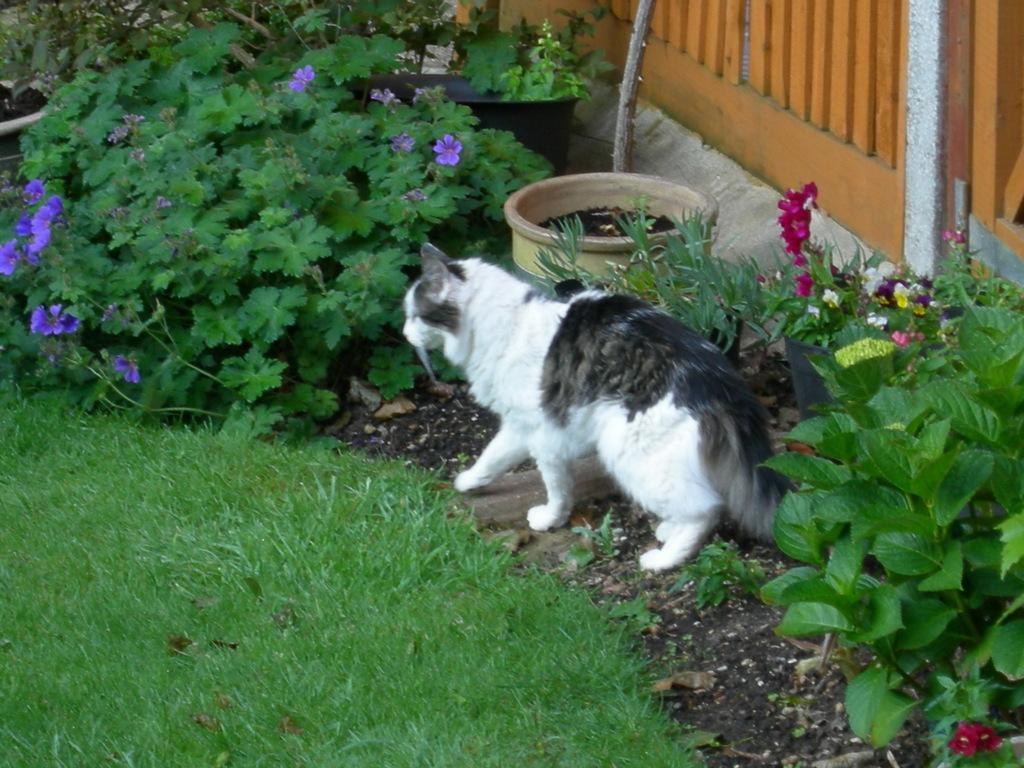What type of surface is visible in the image? There is grass on the surface in the image. What kind of plants can be seen in the image? There are plants with flowers in the image. What animal is present in the image? There is a cat in the image. What type of barrier is on the right side of the image? There is a wooden fence on the right side of the image. What color is the scarf that the cat is wearing in the image? There is no scarf present in the image, and the cat is not wearing any clothing. 